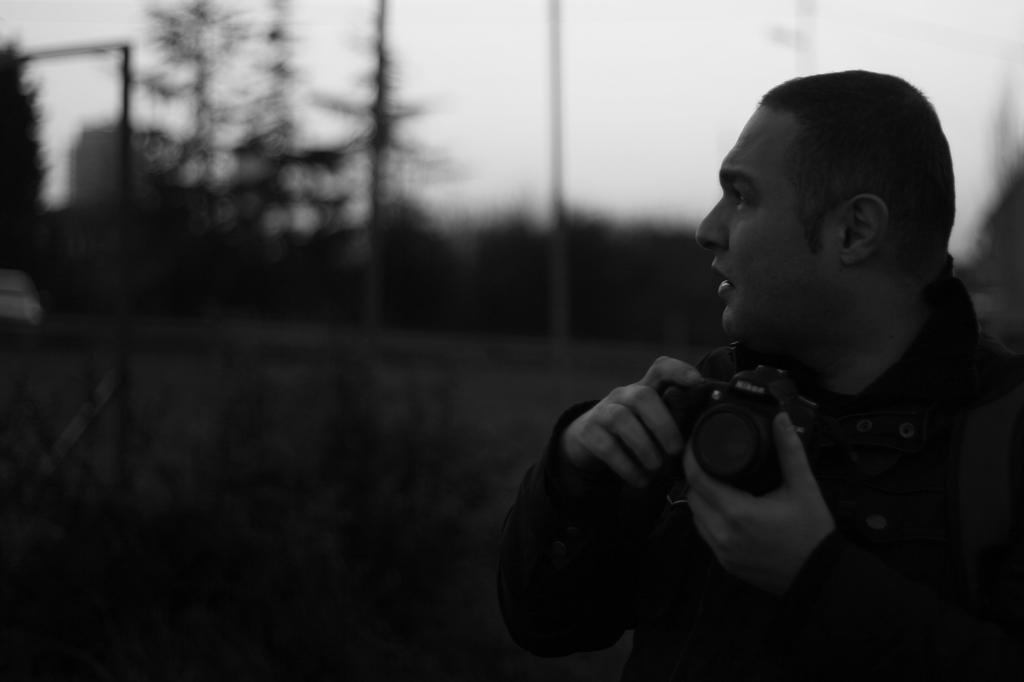What is the color scheme of the image? The image is black and white. What can be seen in the foreground of the image? There is a man standing in the image. What is the man holding in the image? The man is holding a camera. What type of natural scenery is visible in the background of the image? There are trees visible in the background of the image. Can you tell me what type of produce the man is holding in the image? There is no produce visible in the image; the man is holding a camera. Is the man's father present in the image? The provided facts do not mention the presence of the man's father in the image. 